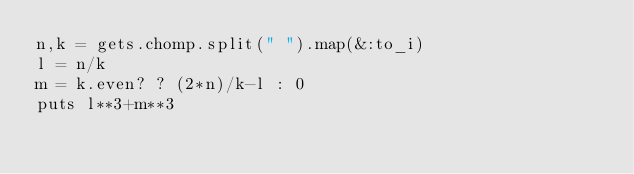Convert code to text. <code><loc_0><loc_0><loc_500><loc_500><_Ruby_>n,k = gets.chomp.split(" ").map(&:to_i)
l = n/k
m = k.even? ? (2*n)/k-l : 0
puts l**3+m**3</code> 